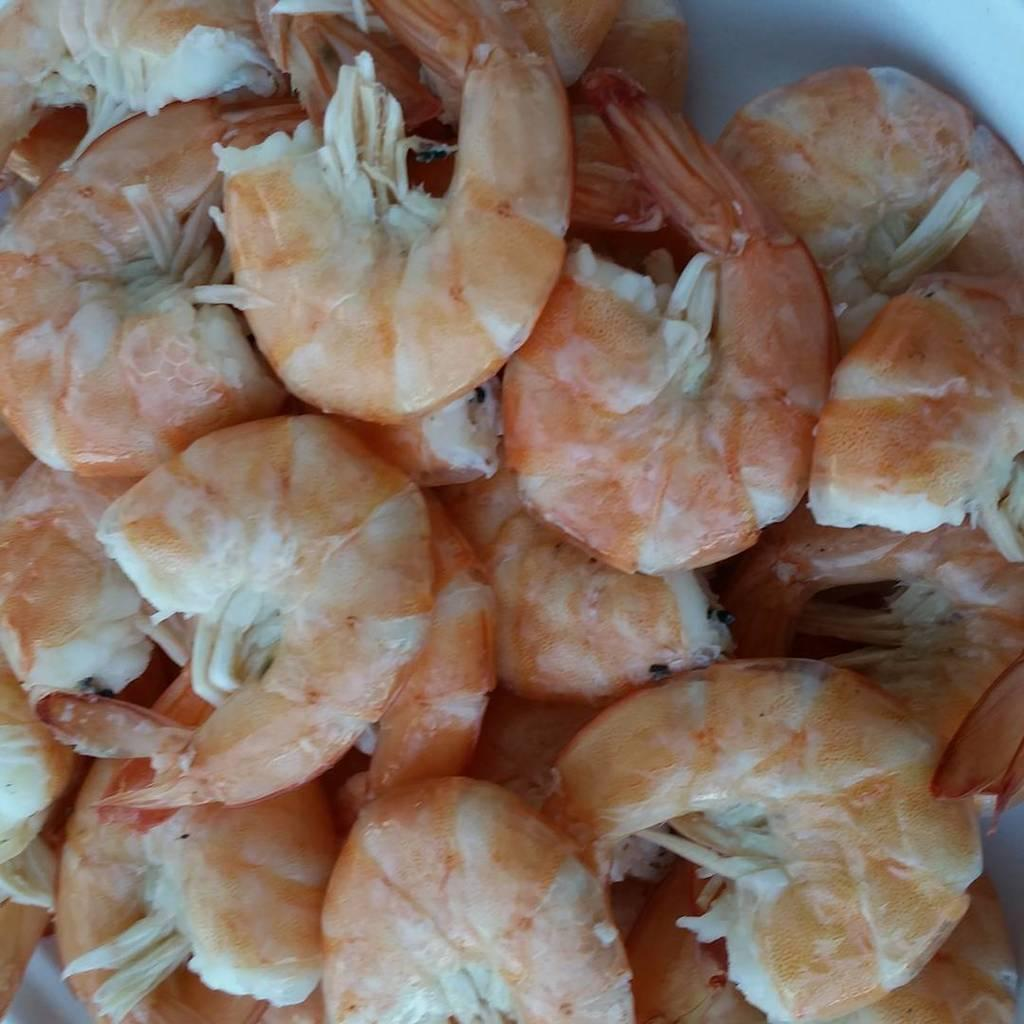What is in the bowl that is visible in the image? There are shrimps in the bowl. Can you describe the contents of the bowl in more detail? The shrimps are visible in the bowl. What type of stocking is being worn by the shrimps in the image? There are no stockings present in the image, as it features a bowl of shrimps. 